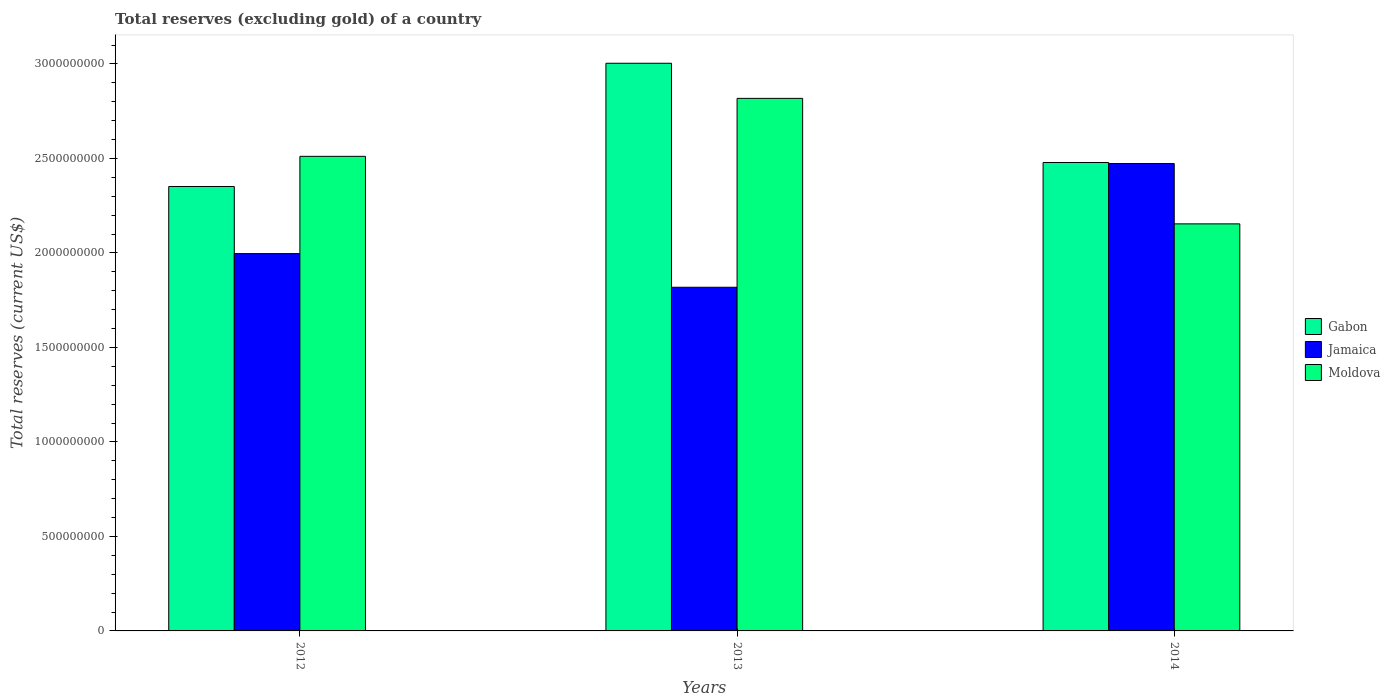How many different coloured bars are there?
Your response must be concise. 3. How many groups of bars are there?
Ensure brevity in your answer.  3. Are the number of bars per tick equal to the number of legend labels?
Make the answer very short. Yes. Are the number of bars on each tick of the X-axis equal?
Make the answer very short. Yes. How many bars are there on the 3rd tick from the right?
Make the answer very short. 3. What is the label of the 3rd group of bars from the left?
Your answer should be compact. 2014. What is the total reserves (excluding gold) in Gabon in 2013?
Offer a terse response. 3.00e+09. Across all years, what is the maximum total reserves (excluding gold) in Gabon?
Your answer should be very brief. 3.00e+09. Across all years, what is the minimum total reserves (excluding gold) in Jamaica?
Provide a succinct answer. 1.82e+09. What is the total total reserves (excluding gold) in Moldova in the graph?
Offer a very short reply. 7.48e+09. What is the difference between the total reserves (excluding gold) in Gabon in 2013 and that in 2014?
Provide a short and direct response. 5.25e+08. What is the difference between the total reserves (excluding gold) in Jamaica in 2014 and the total reserves (excluding gold) in Gabon in 2012?
Your answer should be compact. 1.21e+08. What is the average total reserves (excluding gold) in Moldova per year?
Give a very brief answer. 2.49e+09. In the year 2012, what is the difference between the total reserves (excluding gold) in Jamaica and total reserves (excluding gold) in Moldova?
Give a very brief answer. -5.15e+08. In how many years, is the total reserves (excluding gold) in Moldova greater than 1600000000 US$?
Provide a short and direct response. 3. What is the ratio of the total reserves (excluding gold) in Moldova in 2012 to that in 2013?
Your response must be concise. 0.89. What is the difference between the highest and the second highest total reserves (excluding gold) in Gabon?
Provide a short and direct response. 5.25e+08. What is the difference between the highest and the lowest total reserves (excluding gold) in Jamaica?
Provide a succinct answer. 6.55e+08. What does the 1st bar from the left in 2014 represents?
Provide a short and direct response. Gabon. What does the 2nd bar from the right in 2014 represents?
Make the answer very short. Jamaica. How many bars are there?
Offer a terse response. 9. Are all the bars in the graph horizontal?
Provide a succinct answer. No. What is the difference between two consecutive major ticks on the Y-axis?
Make the answer very short. 5.00e+08. Does the graph contain any zero values?
Keep it short and to the point. No. How many legend labels are there?
Your answer should be very brief. 3. What is the title of the graph?
Make the answer very short. Total reserves (excluding gold) of a country. What is the label or title of the X-axis?
Offer a terse response. Years. What is the label or title of the Y-axis?
Your answer should be compact. Total reserves (current US$). What is the Total reserves (current US$) in Gabon in 2012?
Make the answer very short. 2.35e+09. What is the Total reserves (current US$) in Jamaica in 2012?
Keep it short and to the point. 2.00e+09. What is the Total reserves (current US$) of Moldova in 2012?
Your answer should be compact. 2.51e+09. What is the Total reserves (current US$) in Gabon in 2013?
Give a very brief answer. 3.00e+09. What is the Total reserves (current US$) of Jamaica in 2013?
Ensure brevity in your answer.  1.82e+09. What is the Total reserves (current US$) of Moldova in 2013?
Ensure brevity in your answer.  2.82e+09. What is the Total reserves (current US$) in Gabon in 2014?
Offer a very short reply. 2.48e+09. What is the Total reserves (current US$) of Jamaica in 2014?
Your response must be concise. 2.47e+09. What is the Total reserves (current US$) of Moldova in 2014?
Give a very brief answer. 2.15e+09. Across all years, what is the maximum Total reserves (current US$) of Gabon?
Provide a short and direct response. 3.00e+09. Across all years, what is the maximum Total reserves (current US$) in Jamaica?
Keep it short and to the point. 2.47e+09. Across all years, what is the maximum Total reserves (current US$) in Moldova?
Give a very brief answer. 2.82e+09. Across all years, what is the minimum Total reserves (current US$) in Gabon?
Provide a short and direct response. 2.35e+09. Across all years, what is the minimum Total reserves (current US$) of Jamaica?
Offer a terse response. 1.82e+09. Across all years, what is the minimum Total reserves (current US$) of Moldova?
Your response must be concise. 2.15e+09. What is the total Total reserves (current US$) in Gabon in the graph?
Your answer should be very brief. 7.83e+09. What is the total Total reserves (current US$) in Jamaica in the graph?
Make the answer very short. 6.29e+09. What is the total Total reserves (current US$) of Moldova in the graph?
Offer a very short reply. 7.48e+09. What is the difference between the Total reserves (current US$) of Gabon in 2012 and that in 2013?
Your response must be concise. -6.52e+08. What is the difference between the Total reserves (current US$) of Jamaica in 2012 and that in 2013?
Offer a terse response. 1.78e+08. What is the difference between the Total reserves (current US$) in Moldova in 2012 and that in 2013?
Your answer should be very brief. -3.07e+08. What is the difference between the Total reserves (current US$) in Gabon in 2012 and that in 2014?
Provide a succinct answer. -1.27e+08. What is the difference between the Total reserves (current US$) in Jamaica in 2012 and that in 2014?
Your answer should be compact. -4.77e+08. What is the difference between the Total reserves (current US$) in Moldova in 2012 and that in 2014?
Provide a succinct answer. 3.57e+08. What is the difference between the Total reserves (current US$) of Gabon in 2013 and that in 2014?
Provide a succinct answer. 5.25e+08. What is the difference between the Total reserves (current US$) of Jamaica in 2013 and that in 2014?
Your answer should be very brief. -6.55e+08. What is the difference between the Total reserves (current US$) of Moldova in 2013 and that in 2014?
Give a very brief answer. 6.64e+08. What is the difference between the Total reserves (current US$) of Gabon in 2012 and the Total reserves (current US$) of Jamaica in 2013?
Give a very brief answer. 5.33e+08. What is the difference between the Total reserves (current US$) of Gabon in 2012 and the Total reserves (current US$) of Moldova in 2013?
Ensure brevity in your answer.  -4.66e+08. What is the difference between the Total reserves (current US$) of Jamaica in 2012 and the Total reserves (current US$) of Moldova in 2013?
Your answer should be very brief. -8.21e+08. What is the difference between the Total reserves (current US$) in Gabon in 2012 and the Total reserves (current US$) in Jamaica in 2014?
Offer a very short reply. -1.21e+08. What is the difference between the Total reserves (current US$) of Gabon in 2012 and the Total reserves (current US$) of Moldova in 2014?
Provide a short and direct response. 1.98e+08. What is the difference between the Total reserves (current US$) of Jamaica in 2012 and the Total reserves (current US$) of Moldova in 2014?
Your response must be concise. -1.57e+08. What is the difference between the Total reserves (current US$) in Gabon in 2013 and the Total reserves (current US$) in Jamaica in 2014?
Make the answer very short. 5.31e+08. What is the difference between the Total reserves (current US$) in Gabon in 2013 and the Total reserves (current US$) in Moldova in 2014?
Your response must be concise. 8.50e+08. What is the difference between the Total reserves (current US$) of Jamaica in 2013 and the Total reserves (current US$) of Moldova in 2014?
Make the answer very short. -3.35e+08. What is the average Total reserves (current US$) of Gabon per year?
Make the answer very short. 2.61e+09. What is the average Total reserves (current US$) in Jamaica per year?
Your answer should be compact. 2.10e+09. What is the average Total reserves (current US$) in Moldova per year?
Make the answer very short. 2.49e+09. In the year 2012, what is the difference between the Total reserves (current US$) of Gabon and Total reserves (current US$) of Jamaica?
Your answer should be compact. 3.55e+08. In the year 2012, what is the difference between the Total reserves (current US$) in Gabon and Total reserves (current US$) in Moldova?
Offer a very short reply. -1.59e+08. In the year 2012, what is the difference between the Total reserves (current US$) in Jamaica and Total reserves (current US$) in Moldova?
Make the answer very short. -5.15e+08. In the year 2013, what is the difference between the Total reserves (current US$) in Gabon and Total reserves (current US$) in Jamaica?
Ensure brevity in your answer.  1.19e+09. In the year 2013, what is the difference between the Total reserves (current US$) in Gabon and Total reserves (current US$) in Moldova?
Make the answer very short. 1.86e+08. In the year 2013, what is the difference between the Total reserves (current US$) of Jamaica and Total reserves (current US$) of Moldova?
Ensure brevity in your answer.  -9.99e+08. In the year 2014, what is the difference between the Total reserves (current US$) in Gabon and Total reserves (current US$) in Jamaica?
Your response must be concise. 5.47e+06. In the year 2014, what is the difference between the Total reserves (current US$) of Gabon and Total reserves (current US$) of Moldova?
Make the answer very short. 3.25e+08. In the year 2014, what is the difference between the Total reserves (current US$) in Jamaica and Total reserves (current US$) in Moldova?
Your answer should be compact. 3.19e+08. What is the ratio of the Total reserves (current US$) in Gabon in 2012 to that in 2013?
Provide a succinct answer. 0.78. What is the ratio of the Total reserves (current US$) in Jamaica in 2012 to that in 2013?
Make the answer very short. 1.1. What is the ratio of the Total reserves (current US$) of Moldova in 2012 to that in 2013?
Offer a terse response. 0.89. What is the ratio of the Total reserves (current US$) of Gabon in 2012 to that in 2014?
Your response must be concise. 0.95. What is the ratio of the Total reserves (current US$) in Jamaica in 2012 to that in 2014?
Give a very brief answer. 0.81. What is the ratio of the Total reserves (current US$) of Moldova in 2012 to that in 2014?
Your answer should be very brief. 1.17. What is the ratio of the Total reserves (current US$) in Gabon in 2013 to that in 2014?
Give a very brief answer. 1.21. What is the ratio of the Total reserves (current US$) of Jamaica in 2013 to that in 2014?
Keep it short and to the point. 0.74. What is the ratio of the Total reserves (current US$) of Moldova in 2013 to that in 2014?
Keep it short and to the point. 1.31. What is the difference between the highest and the second highest Total reserves (current US$) in Gabon?
Your answer should be compact. 5.25e+08. What is the difference between the highest and the second highest Total reserves (current US$) in Jamaica?
Ensure brevity in your answer.  4.77e+08. What is the difference between the highest and the second highest Total reserves (current US$) in Moldova?
Your response must be concise. 3.07e+08. What is the difference between the highest and the lowest Total reserves (current US$) in Gabon?
Your response must be concise. 6.52e+08. What is the difference between the highest and the lowest Total reserves (current US$) of Jamaica?
Provide a succinct answer. 6.55e+08. What is the difference between the highest and the lowest Total reserves (current US$) of Moldova?
Ensure brevity in your answer.  6.64e+08. 